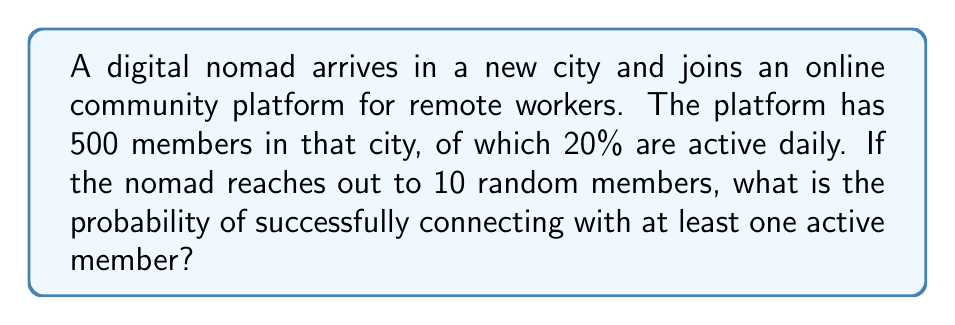Solve this math problem. Let's approach this step-by-step:

1) First, we need to calculate the probability of a single member being active:
   $p(\text{active}) = 20\% = 0.2$

2) The probability of a member not being active is:
   $p(\text{not active}) = 1 - 0.2 = 0.8$

3) Now, we want to find the probability of connecting with at least one active member out of 10 attempts. It's easier to calculate the probability of not connecting with any active members and then subtract this from 1.

4) The probability of not connecting with an active member in a single attempt is 0.8.

5) For all 10 attempts to fail, each one must fail independently. So we multiply the probability:
   $p(\text{all 10 not active}) = 0.8^{10}$

6) We can calculate this:
   $0.8^{10} \approx 0.1074$

7) Therefore, the probability of connecting with at least one active member is:
   $p(\text{at least one active}) = 1 - p(\text{all 10 not active})$
   $= 1 - 0.1074 = 0.8926$

8) Converting to a percentage:
   $0.8926 \times 100\% = 89.26\%$
Answer: 89.26% 